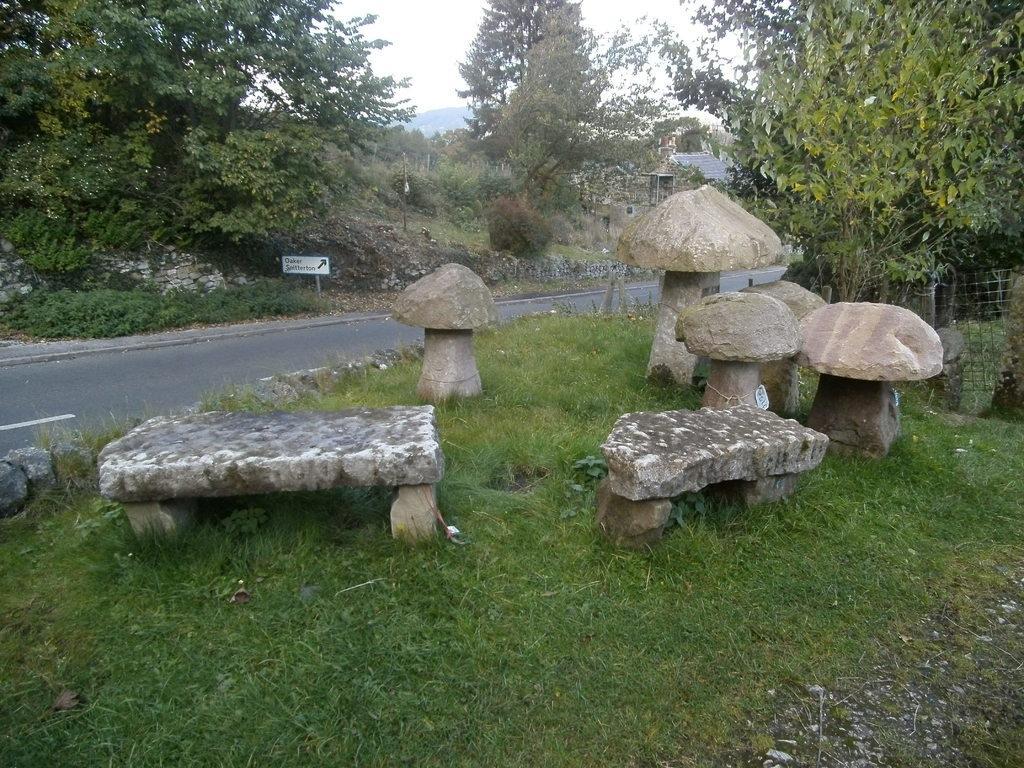Please provide a concise description of this image. This picture is clicked outside the city. At the bottom of the picture, we see grass. Beside that, there are benches which are made up of stones. Behind them, we see the stones are carved in the shape of a mushroom. Behind that, we see the road. Beside that, there are trees. In the background, there are trees. 